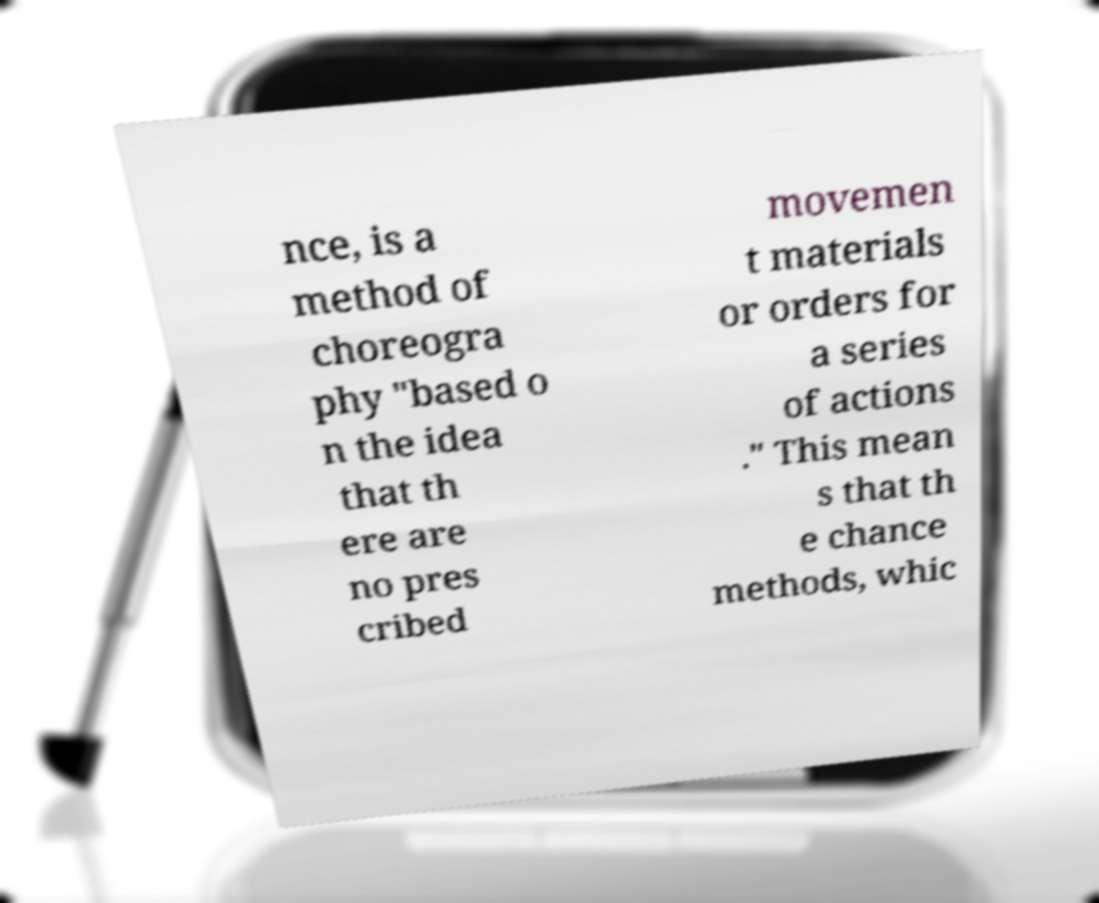There's text embedded in this image that I need extracted. Can you transcribe it verbatim? nce, is a method of choreogra phy "based o n the idea that th ere are no pres cribed movemen t materials or orders for a series of actions ." This mean s that th e chance methods, whic 